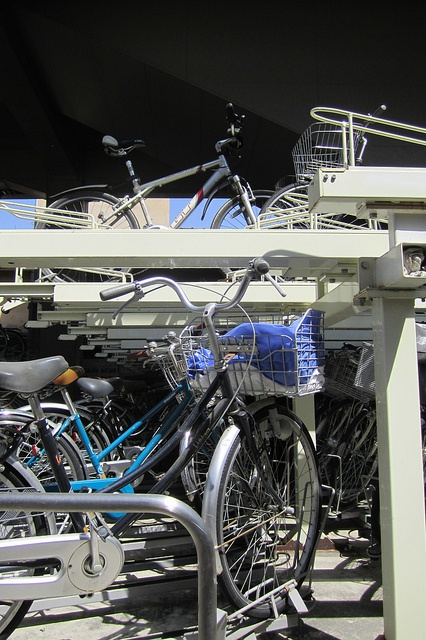Describe the objects in this image and their specific colors. I can see bicycle in black, gray, darkgray, and lightgray tones, bicycle in black, gray, lightgray, and lightblue tones, bicycle in black, gray, darkgray, and lightblue tones, backpack in black, navy, gray, and blue tones, and bicycle in black, gray, ivory, and darkgray tones in this image. 